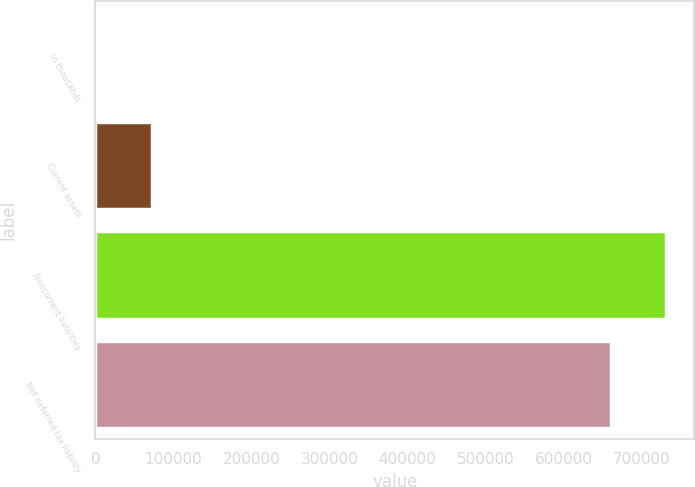<chart> <loc_0><loc_0><loc_500><loc_500><bar_chart><fcel>in thousands<fcel>Current assets<fcel>Noncurrent liabilities<fcel>Net deferred tax liability<nl><fcel>2013<fcel>71919.2<fcel>730558<fcel>660652<nl></chart> 